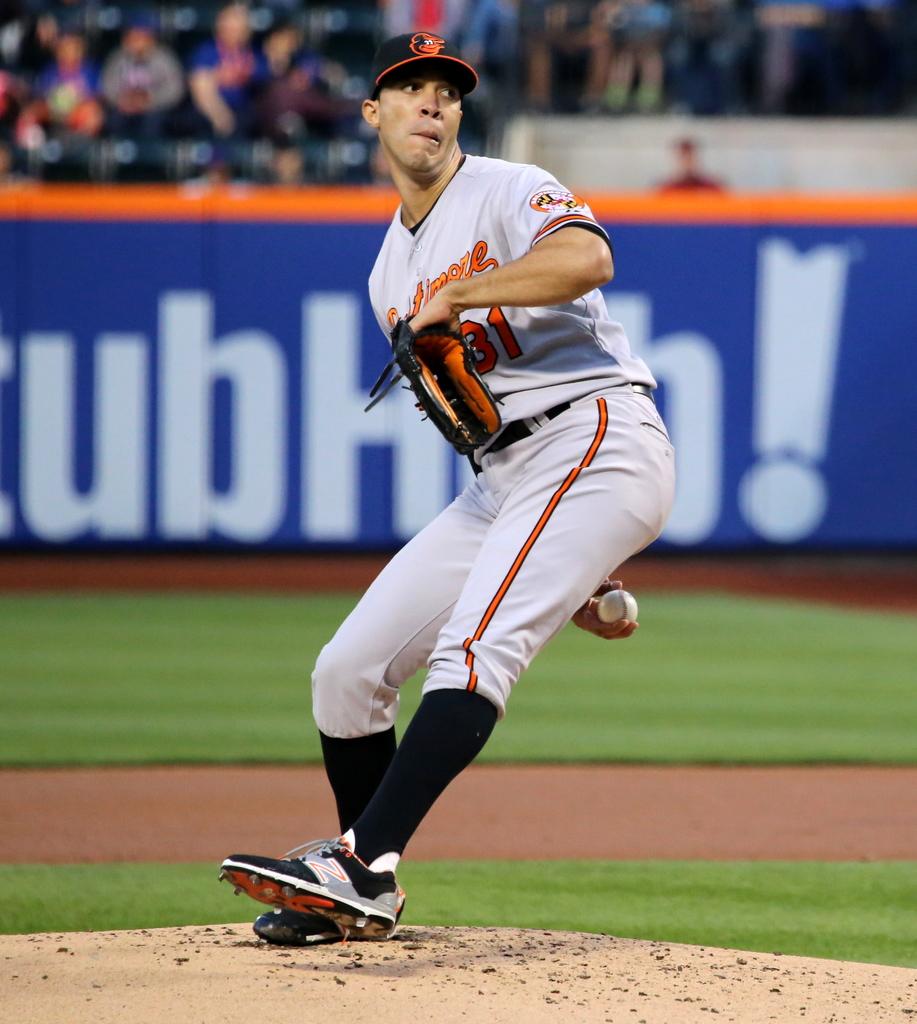What number is he wearing?
Provide a short and direct response. 31. 